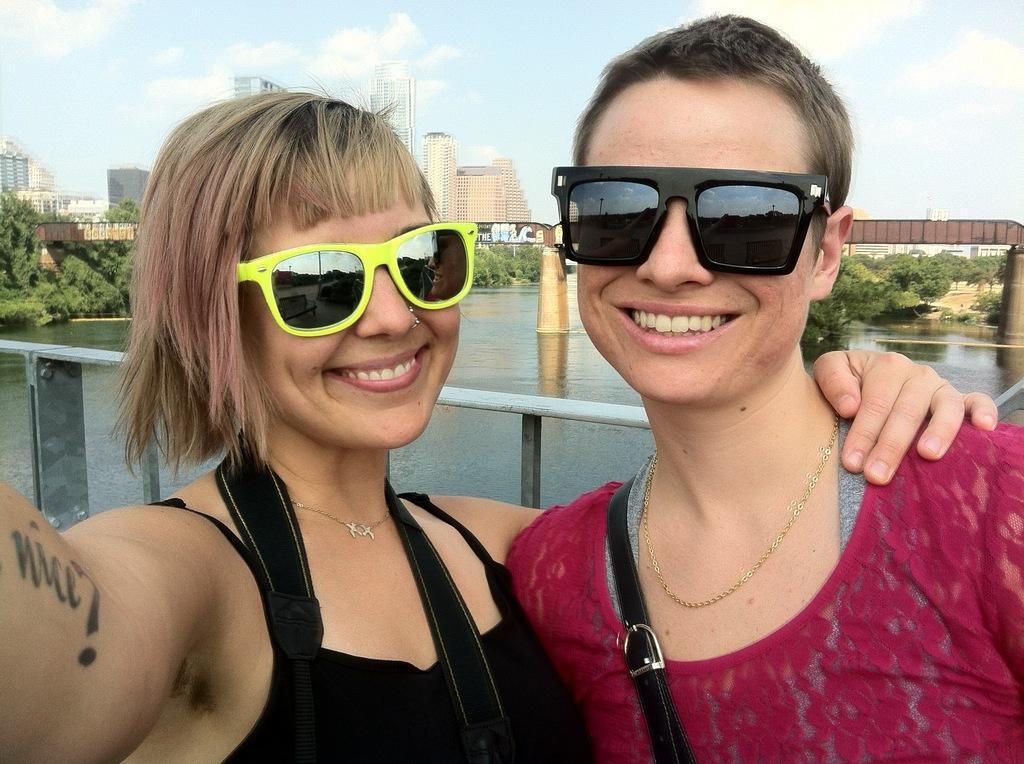In one or two sentences, can you explain what this image depicts? In front of the picture, we see two women are standing. Both of them are wearing goggles. They are smiling. Both of them are posing for the photo. Behind them, we see a railing. Behind them, we see water and this water might be in the lake. We see a bridge. There are trees and buildings in the background. At the top of the picture, we see the sky and the clouds. 